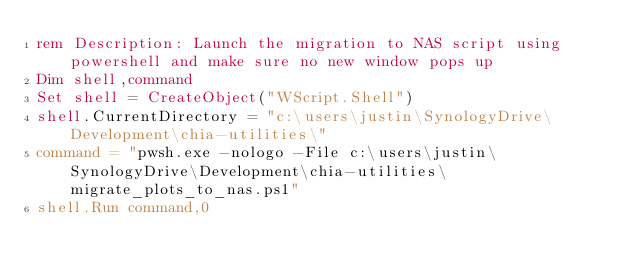<code> <loc_0><loc_0><loc_500><loc_500><_VisualBasic_>rem Description: Launch the migration to NAS script using powershell and make sure no new window pops up
Dim shell,command
Set shell = CreateObject("WScript.Shell")
shell.CurrentDirectory = "c:\users\justin\SynologyDrive\Development\chia-utilities\"
command = "pwsh.exe -nologo -File c:\users\justin\SynologyDrive\Development\chia-utilities\migrate_plots_to_nas.ps1"
shell.Run command,0</code> 